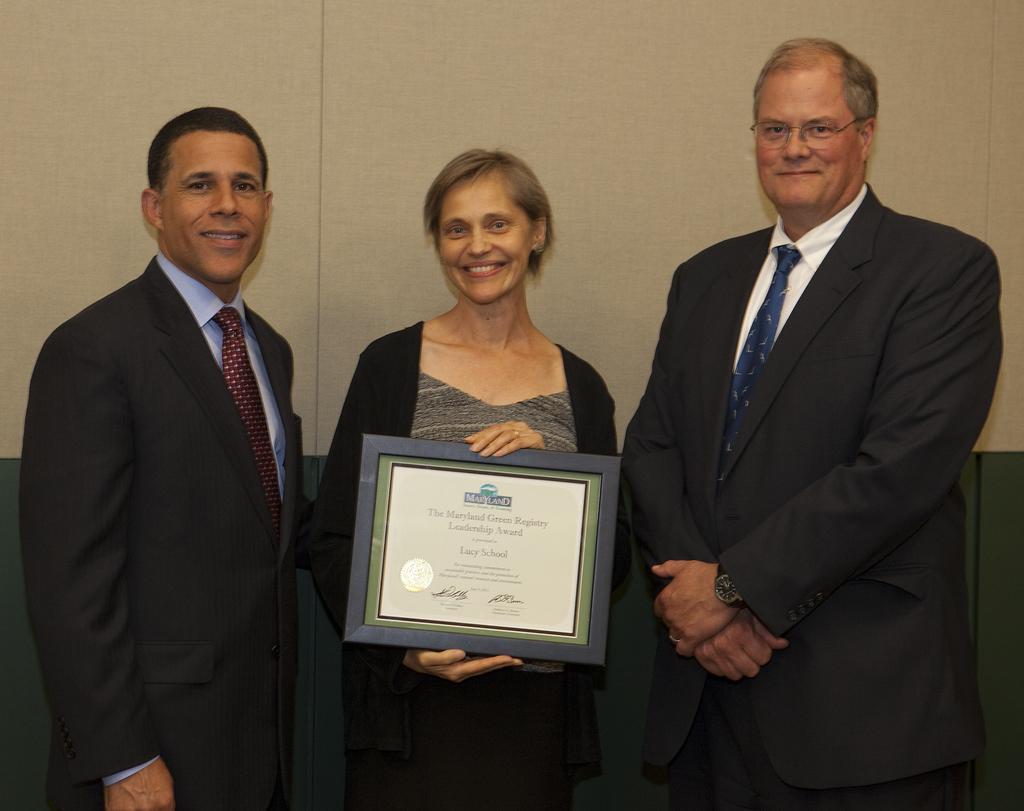How would you summarize this image in a sentence or two? In this image, we can see people wearing clothes. There is a person in the middle of the image holding a memorandum with her hands. In the background, we can see a wall. 